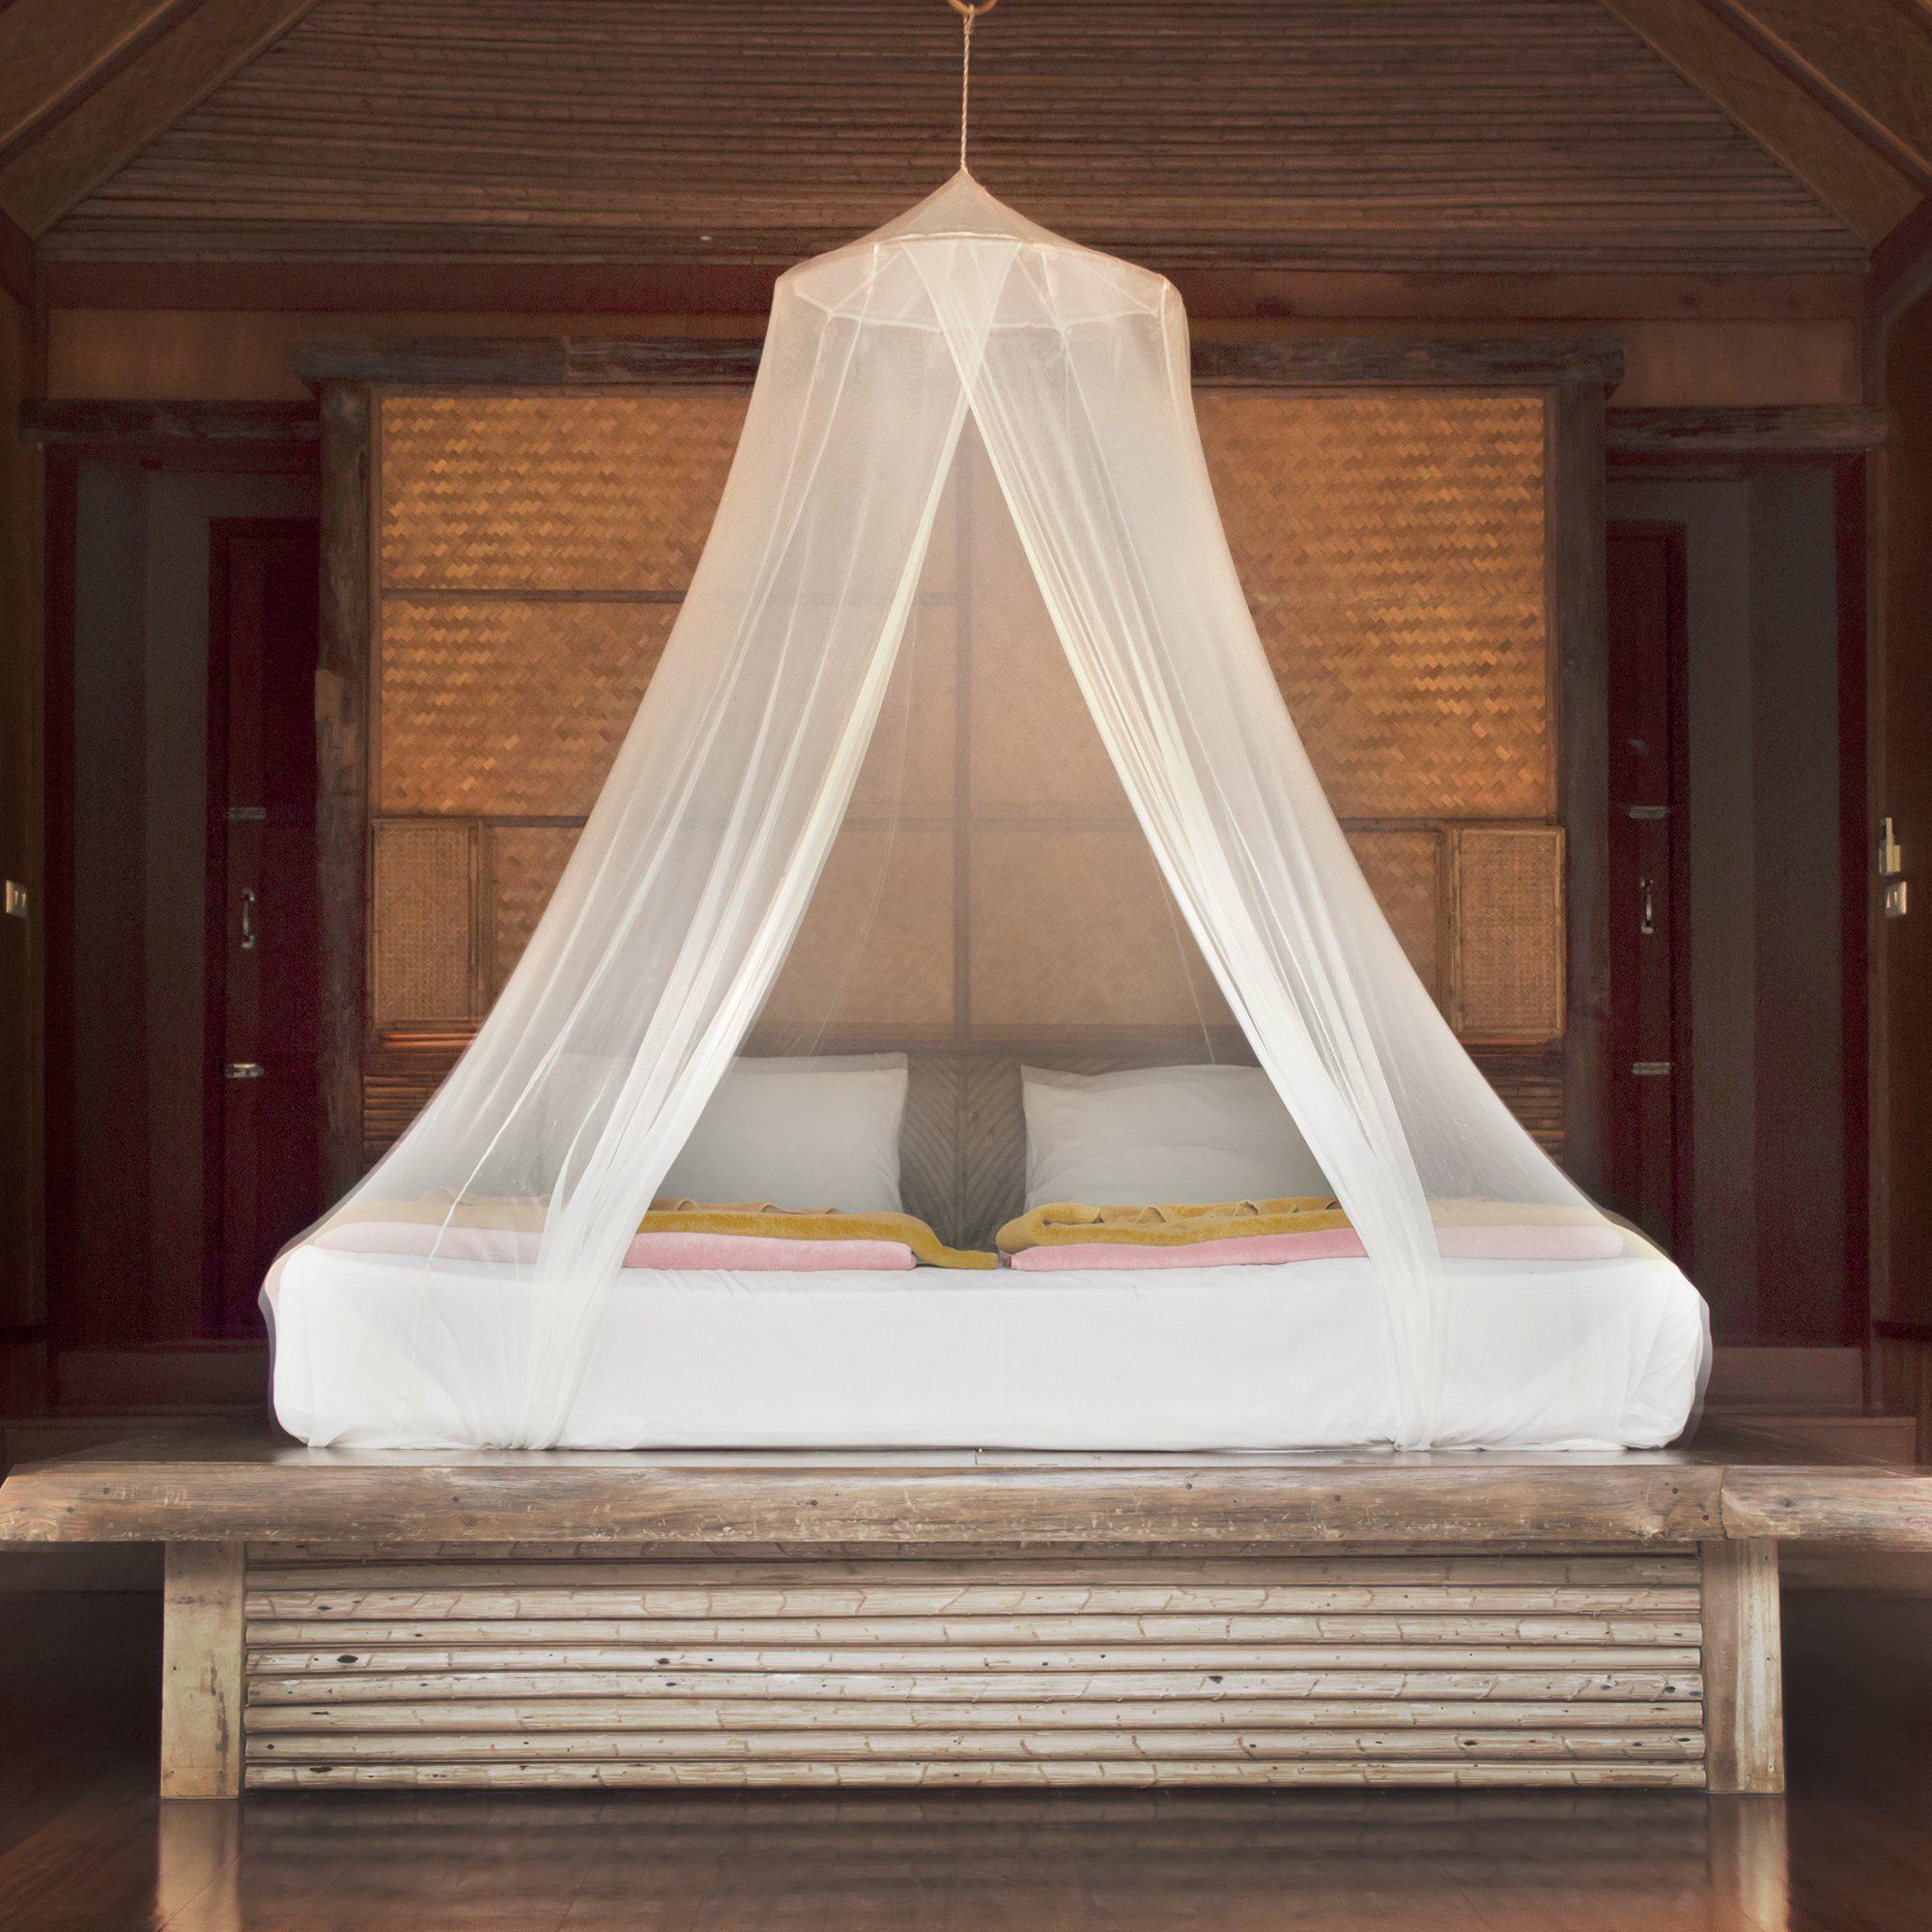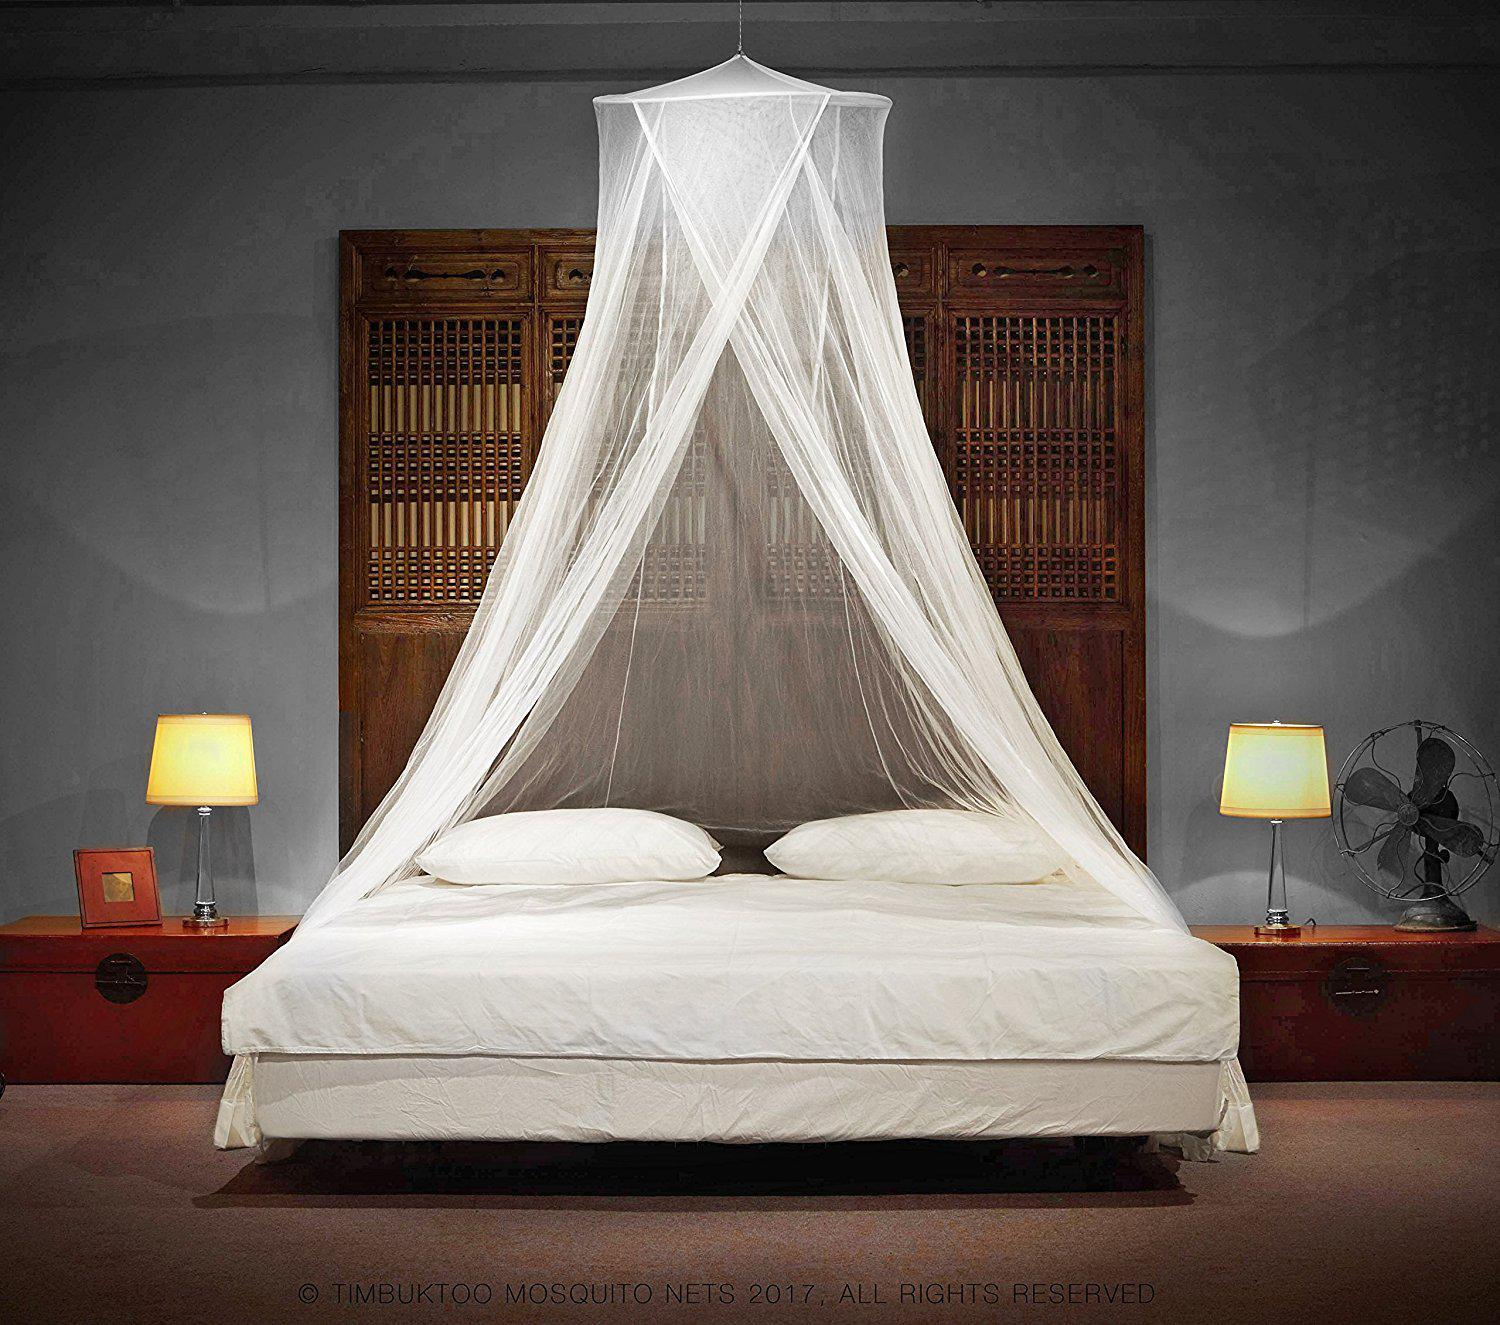The first image is the image on the left, the second image is the image on the right. For the images displayed, is the sentence "There are two round canopies." factually correct? Answer yes or no. Yes. The first image is the image on the left, the second image is the image on the right. Evaluate the accuracy of this statement regarding the images: "There are two circle canopies.". Is it true? Answer yes or no. Yes. 